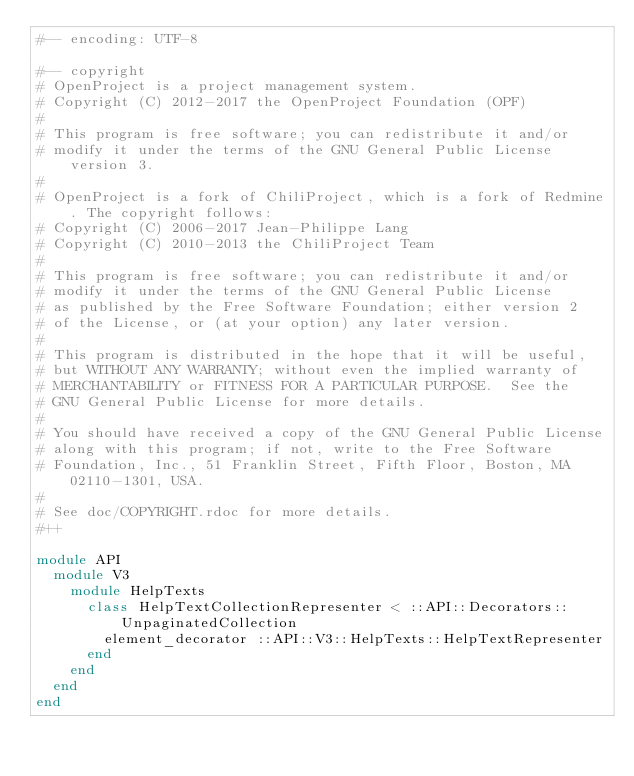Convert code to text. <code><loc_0><loc_0><loc_500><loc_500><_Ruby_>#-- encoding: UTF-8

#-- copyright
# OpenProject is a project management system.
# Copyright (C) 2012-2017 the OpenProject Foundation (OPF)
#
# This program is free software; you can redistribute it and/or
# modify it under the terms of the GNU General Public License version 3.
#
# OpenProject is a fork of ChiliProject, which is a fork of Redmine. The copyright follows:
# Copyright (C) 2006-2017 Jean-Philippe Lang
# Copyright (C) 2010-2013 the ChiliProject Team
#
# This program is free software; you can redistribute it and/or
# modify it under the terms of the GNU General Public License
# as published by the Free Software Foundation; either version 2
# of the License, or (at your option) any later version.
#
# This program is distributed in the hope that it will be useful,
# but WITHOUT ANY WARRANTY; without even the implied warranty of
# MERCHANTABILITY or FITNESS FOR A PARTICULAR PURPOSE.  See the
# GNU General Public License for more details.
#
# You should have received a copy of the GNU General Public License
# along with this program; if not, write to the Free Software
# Foundation, Inc., 51 Franklin Street, Fifth Floor, Boston, MA  02110-1301, USA.
#
# See doc/COPYRIGHT.rdoc for more details.
#++

module API
  module V3
    module HelpTexts
      class HelpTextCollectionRepresenter < ::API::Decorators::UnpaginatedCollection
        element_decorator ::API::V3::HelpTexts::HelpTextRepresenter
      end
    end
  end
end
</code> 